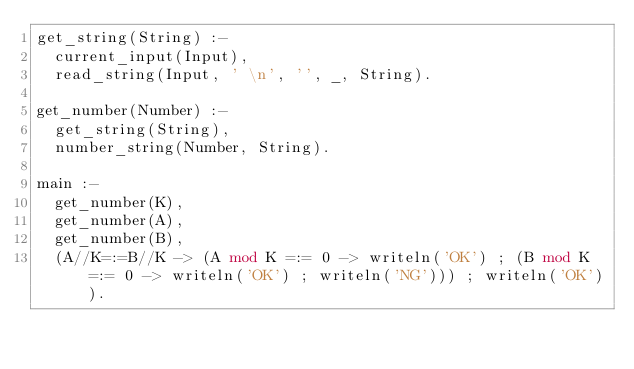Convert code to text. <code><loc_0><loc_0><loc_500><loc_500><_Prolog_>get_string(String) :-
  current_input(Input),
  read_string(Input, ' \n', '', _, String).
 
get_number(Number) :-
  get_string(String),
  number_string(Number, String).
 
main :-
  get_number(K),
  get_number(A),
  get_number(B),
  (A//K=:=B//K -> (A mod K =:= 0 -> writeln('OK') ; (B mod K =:= 0 -> writeln('OK') ; writeln('NG'))) ; writeln('OK')).</code> 